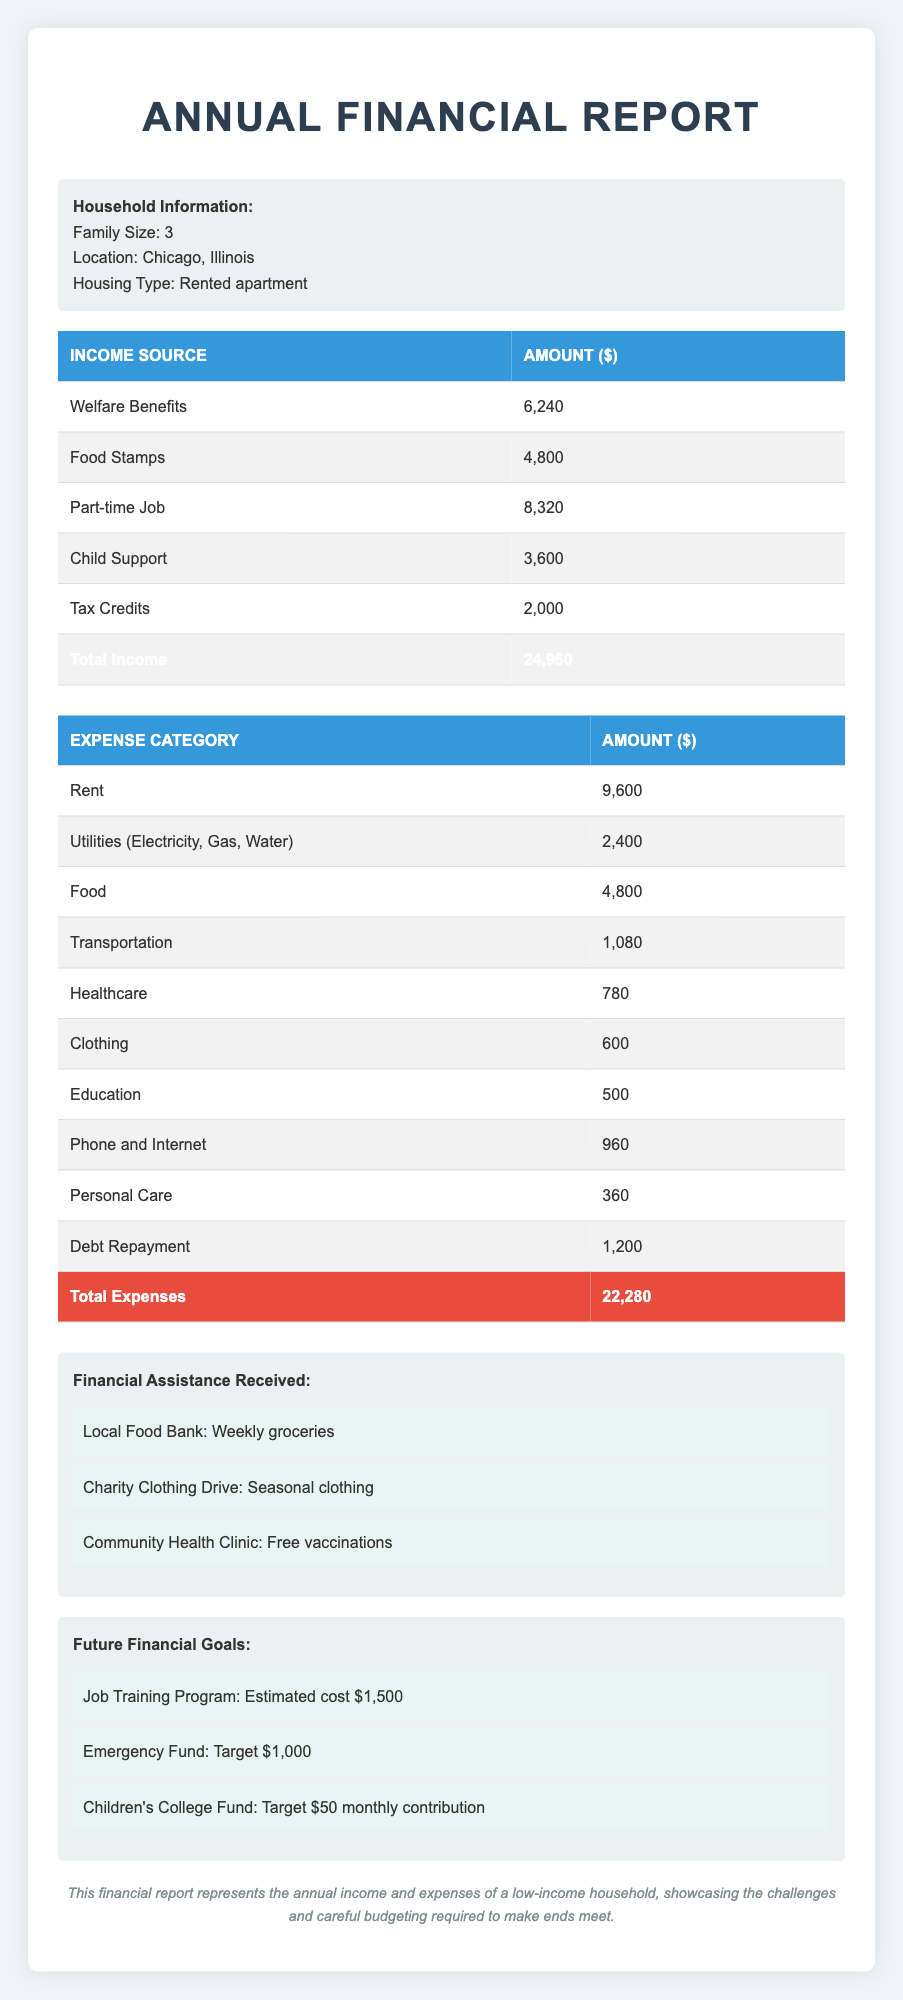What is the total annual income for the household? The total annual income is calculated by adding all the income sources together: Welfare Benefits (6240) + Food Stamps (4800) + Part-time Job (8320) + Child Support (3600) + Tax Credits (2000) = 24960.
Answer: 24960 How much does the household spend on rent annually? The table indicates that the household spends 9600 on rent each year.
Answer: 9600 What is the total amount spent on healthcare? The total healthcare expenses include Copays (300) and Prescriptions (480). Adding these amounts gives: 300 + 480 = 780.
Answer: 780 Are the annual expenses greater than the annual income? To determine this, we compare total annual expenses (22280) with total annual income (24960). Since 24960 is greater than 22280, the statement is false.
Answer: No How much money is left after accounting for all expenses? To find the remaining amount, subtract total expenses (22280) from total income (24960): 24960 - 22280 = 2680.
Answer: 2680 What percentage of the total income is allocated to food expenses? The food expenses are 4800, and the total income is 24960. The percentage is calculated as (4800 / 24960) * 100 = 19.23%.
Answer: 19.23% How much more is spent on rent compared to clothing? Rent expenses are 9600 and clothing expenses are 600. The difference is 9600 - 600 = 9000, indicating rent is significantly higher.
Answer: 9000 What is the total spent on transportation? The total transportation expense includes Public Transit (840) and Occasional Taxi (240). Thus, the total is 840 + 240 = 1080.
Answer: 1080 What financial assistance does the household receive? The household receives assistance from a Local Food Bank for weekly groceries, a Charity Clothing Drive for seasonal clothing, and a Community Health Clinic for free vaccinations.
Answer: Weekly groceries, seasonal clothing, free vaccinations 